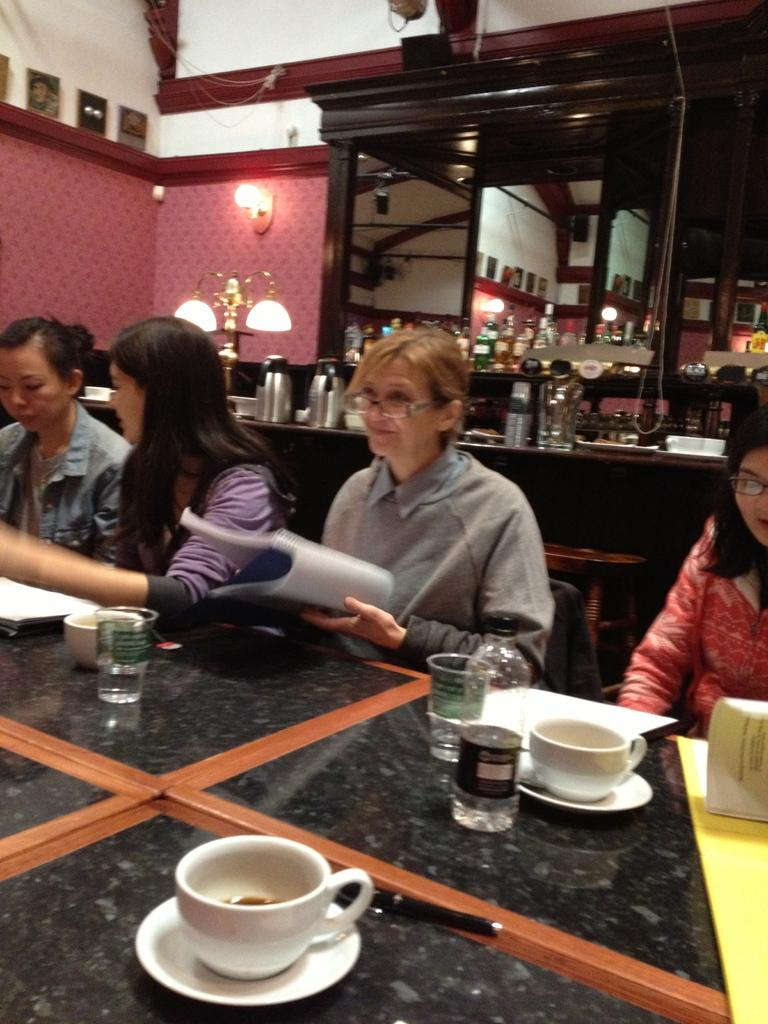How many people are in the image? There are four persons in the image. What are the persons doing in the image? The persons are sitting on a chair. What is in front of the persons? There is a table in front of the persons. What can be seen on the table? There are objects on the table. What is visible behind the persons? There are wine bottles visible behind the persons. What organization is responsible for the spark in the image? There is no spark present in the image, and therefore no organization is responsible for it. 